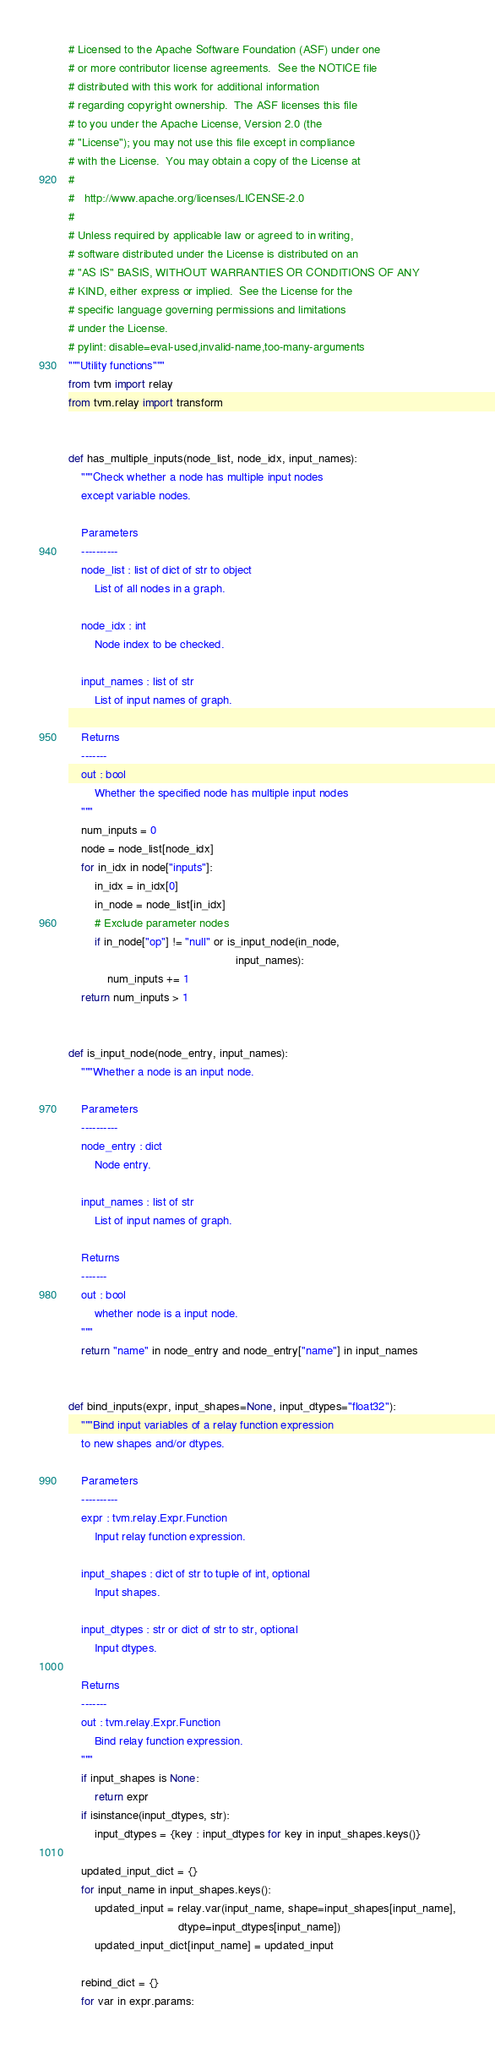Convert code to text. <code><loc_0><loc_0><loc_500><loc_500><_Python_># Licensed to the Apache Software Foundation (ASF) under one
# or more contributor license agreements.  See the NOTICE file
# distributed with this work for additional information
# regarding copyright ownership.  The ASF licenses this file
# to you under the Apache License, Version 2.0 (the
# "License"); you may not use this file except in compliance
# with the License.  You may obtain a copy of the License at
#
#   http://www.apache.org/licenses/LICENSE-2.0
#
# Unless required by applicable law or agreed to in writing,
# software distributed under the License is distributed on an
# "AS IS" BASIS, WITHOUT WARRANTIES OR CONDITIONS OF ANY
# KIND, either express or implied.  See the License for the
# specific language governing permissions and limitations
# under the License.
# pylint: disable=eval-used,invalid-name,too-many-arguments
"""Utility functions"""
from tvm import relay
from tvm.relay import transform


def has_multiple_inputs(node_list, node_idx, input_names):
    """Check whether a node has multiple input nodes
    except variable nodes.

    Parameters
    ----------
    node_list : list of dict of str to object
        List of all nodes in a graph.

    node_idx : int
        Node index to be checked.

    input_names : list of str
        List of input names of graph.

    Returns
    -------
    out : bool
        Whether the specified node has multiple input nodes
    """
    num_inputs = 0
    node = node_list[node_idx]
    for in_idx in node["inputs"]:
        in_idx = in_idx[0]
        in_node = node_list[in_idx]
        # Exclude parameter nodes
        if in_node["op"] != "null" or is_input_node(in_node,
                                                    input_names):
            num_inputs += 1
    return num_inputs > 1


def is_input_node(node_entry, input_names):
    """Whether a node is an input node.

    Parameters
    ----------
    node_entry : dict
        Node entry.

    input_names : list of str
        List of input names of graph.

    Returns
    -------
    out : bool
        whether node is a input node.
    """
    return "name" in node_entry and node_entry["name"] in input_names


def bind_inputs(expr, input_shapes=None, input_dtypes="float32"):
    """Bind input variables of a relay function expression
    to new shapes and/or dtypes.

    Parameters
    ----------
    expr : tvm.relay.Expr.Function
        Input relay function expression.

    input_shapes : dict of str to tuple of int, optional
        Input shapes.

    input_dtypes : str or dict of str to str, optional
        Input dtypes.

    Returns
    -------
    out : tvm.relay.Expr.Function
        Bind relay function expression.
    """
    if input_shapes is None:
        return expr
    if isinstance(input_dtypes, str):
        input_dtypes = {key : input_dtypes for key in input_shapes.keys()}

    updated_input_dict = {}
    for input_name in input_shapes.keys():
        updated_input = relay.var(input_name, shape=input_shapes[input_name],
                                  dtype=input_dtypes[input_name])
        updated_input_dict[input_name] = updated_input

    rebind_dict = {}
    for var in expr.params:</code> 